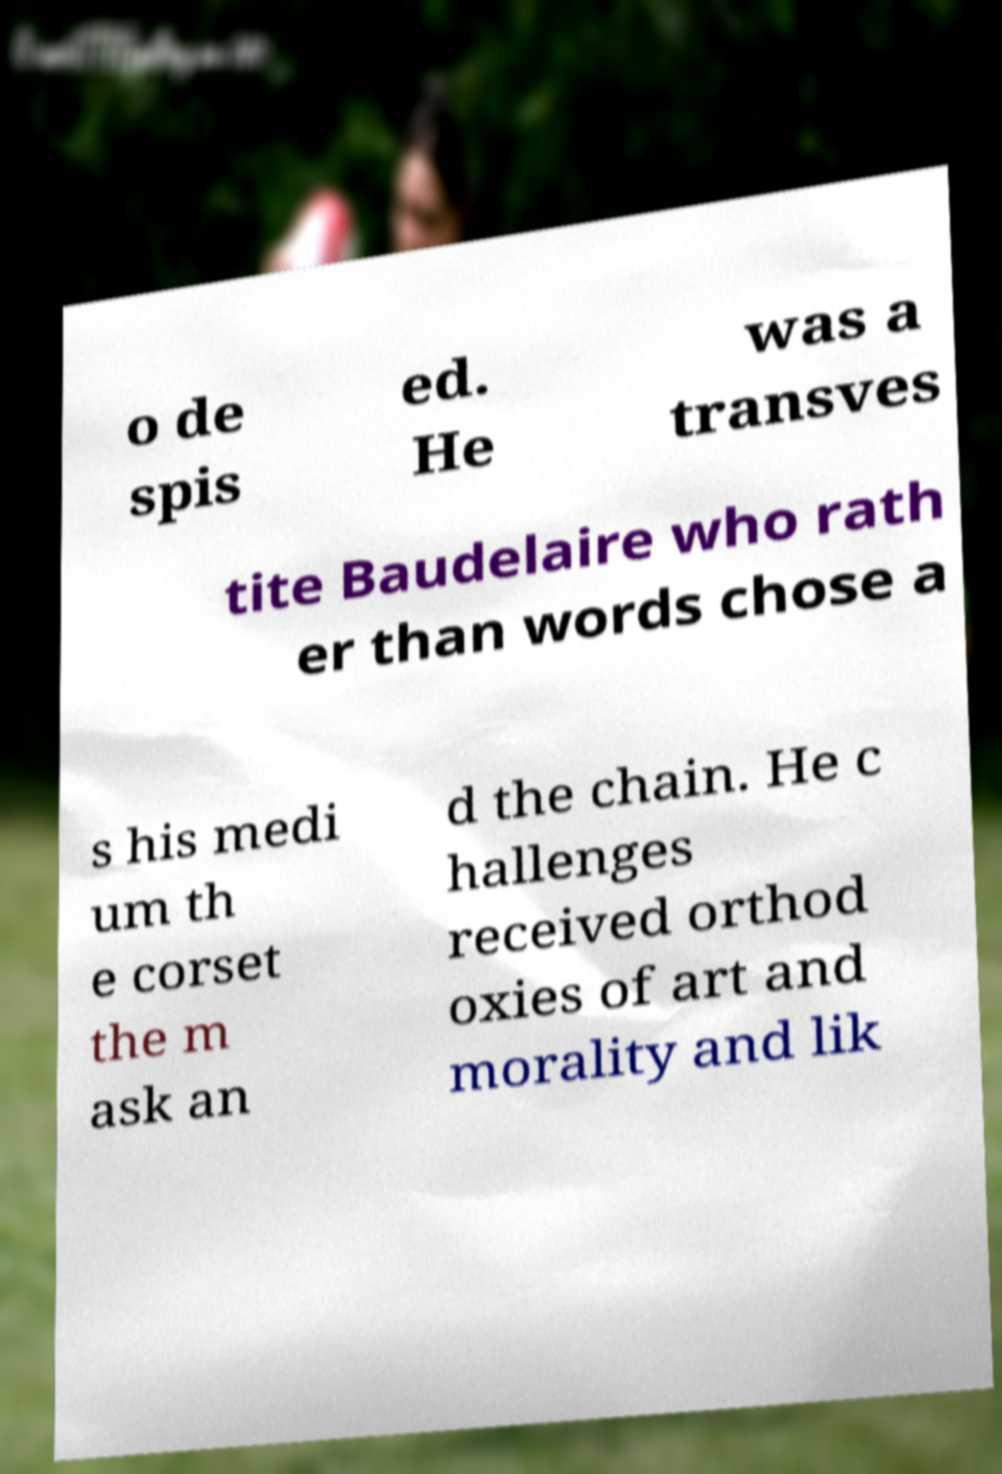I need the written content from this picture converted into text. Can you do that? o de spis ed. He was a transves tite Baudelaire who rath er than words chose a s his medi um th e corset the m ask an d the chain. He c hallenges received orthod oxies of art and morality and lik 